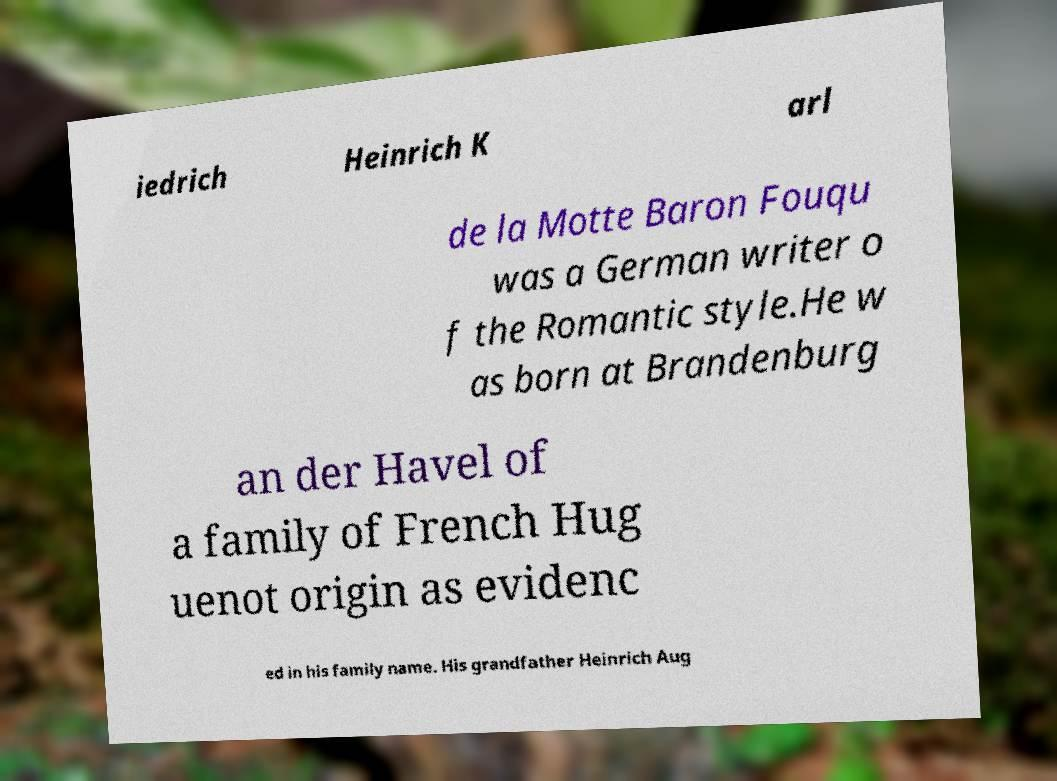Could you assist in decoding the text presented in this image and type it out clearly? iedrich Heinrich K arl de la Motte Baron Fouqu was a German writer o f the Romantic style.He w as born at Brandenburg an der Havel of a family of French Hug uenot origin as evidenc ed in his family name. His grandfather Heinrich Aug 